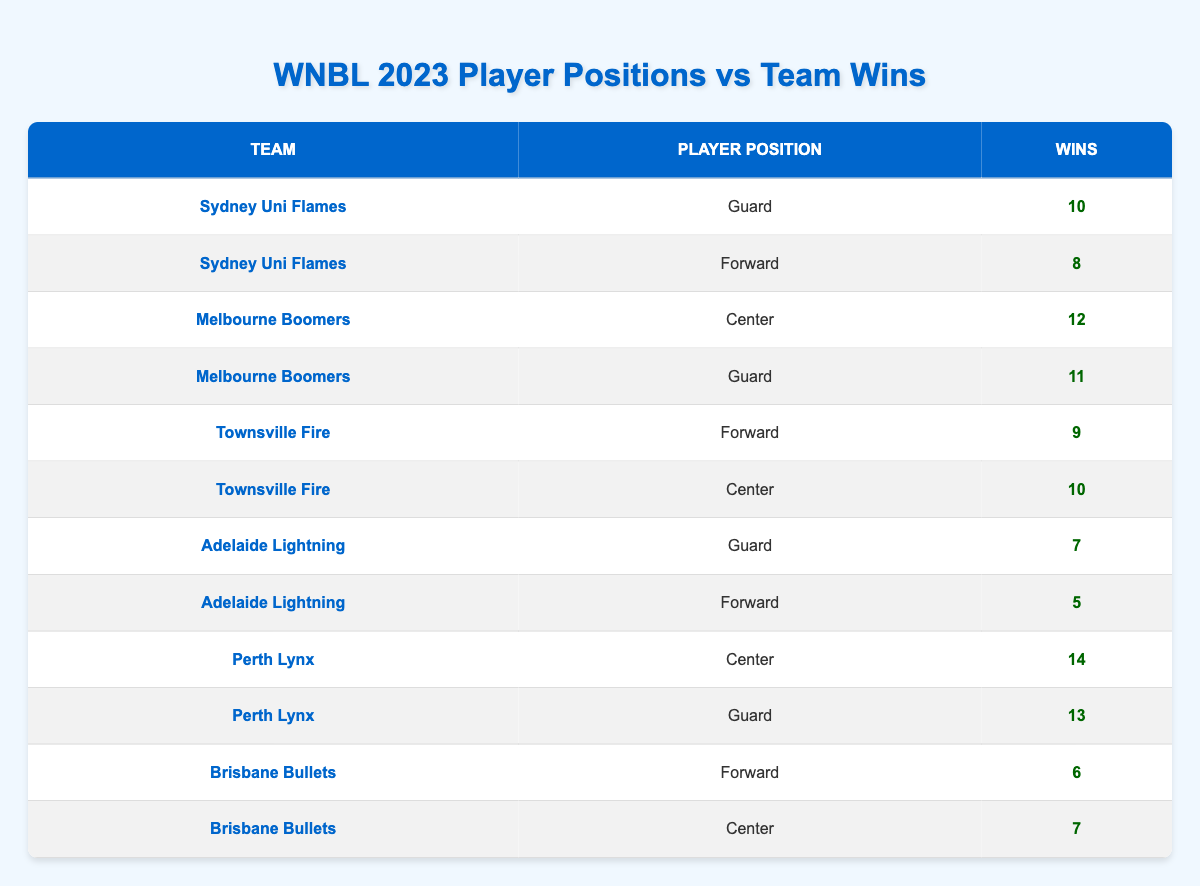What's the highest number of wins recorded by a player position in the table? The highest number of wins recorded is 14 by the Center position of the Perth Lynx. This can be found by scanning the "Wins" column and identifying the maximum value.
Answer: 14 Which team had the most wins by Guards? The Perth Lynx had the highest number of wins by Guards, totaling 13 wins. This is found by comparing the wins of Guards from each team.
Answer: Perth Lynx What is the total number of wins for the Townsville Fire? The Townsville Fire has a total of 19 wins, calculated by adding the wins of Forward (9) and Center (10) positions together. (9 + 10 = 19)
Answer: 19 Did any team have a player position with fewer than 5 wins? Yes, the Adelaide Lightning had a Forward position with only 5 wins. This can be confirmed by checking the "Wins" column for each team and position.
Answer: Yes What is the average number of wins for all the Center positions? To find the average number of wins for Center positions, first identify their win counts: 12 (Melbourne Boomers), 10 (Townsville Fire), and 14 (Perth Lynx). The sum is (12 + 10 + 14) = 36. There are 3 data points so the average is 36 divided by 3, which equals 12.
Answer: 12 Which team had a higher win count: the Sydney Uni Flames or the Adelaide Lightning? The Sydney Uni Flames had a total of 18 wins (10 for Guards and 8 for Forwards) while the Adelaide Lightning had a total of 12 wins (7 for Guards and 5 for Forwards). Therefore, Sydney Uni Flames had a higher win count.
Answer: Sydney Uni Flames How many wins did the Brisbane Bullets achieve in total? The Brisbane Bullets achieved a total of 13 wins, found by adding the wins of Forward (6) and Center (7) positions together. (6 + 7 = 13)
Answer: 13 What is the difference in the number of wins between the top team and the bottom team? The top team is Perth Lynx with 14 wins (Center) and the bottom team is Adelaide Lightning with 12 wins (total). The difference is calculated as 14 (Perth Lynx) - 12 (Adelaide Lightning) = 2.
Answer: 2 